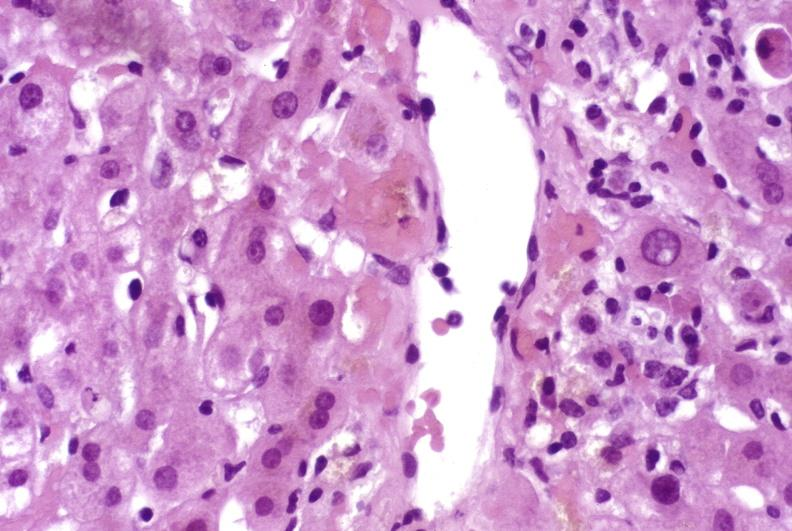does this image show mild acute rejection?
Answer the question using a single word or phrase. Yes 